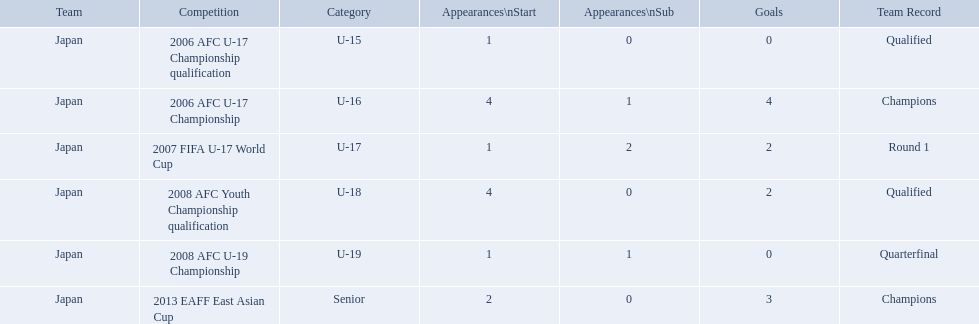Which competitions had champions team records? 2006 AFC U-17 Championship, 2013 EAFF East Asian Cup. Of these competitions, which one was in the senior category? 2013 EAFF East Asian Cup. Which contests featured champion team performances? 2006 AFC U-17 Championship, 2013 EAFF East Asian Cup. Among these contests, which one belonged to the senior category? 2013 EAFF East Asian Cup. In which events did winning teams set records? 2006 AFC U-17 Championship, 2013 EAFF East Asian Cup. Out of these events, which one was within the senior division? 2013 EAFF East Asian Cup. Help me parse the entirety of this table. {'header': ['Team', 'Competition', 'Category', 'Appearances\\nStart', 'Appearances\\nSub', 'Goals', 'Team Record'], 'rows': [['Japan', '2006 AFC U-17 Championship qualification', 'U-15', '1', '0', '0', 'Qualified'], ['Japan', '2006 AFC U-17 Championship', 'U-16', '4', '1', '4', 'Champions'], ['Japan', '2007 FIFA U-17 World Cup', 'U-17', '1', '2', '2', 'Round 1'], ['Japan', '2008 AFC Youth Championship qualification', 'U-18', '4', '0', '2', 'Qualified'], ['Japan', '2008 AFC U-19 Championship', 'U-19', '1', '1', '0', 'Quarterfinal'], ['Japan', '2013 EAFF East Asian Cup', 'Senior', '2', '0', '3', 'Champions']]} What are all the contests? 2006 AFC U-17 Championship qualification, 2006 AFC U-17 Championship, 2007 FIFA U-17 World Cup, 2008 AFC Youth Championship qualification, 2008 AFC U-19 Championship, 2013 EAFF East Asian Cup. How many initial appearances were there? 1, 4, 1, 4, 1, 2. What about specifically during the 2013 eaff east asian cup and the 2007 fifa u-17 world cup? 1, 2. Which of those had more starting appearances? 2013 EAFF East Asian Cup. What are all the tournaments? 2006 AFC U-17 Championship qualification, 2006 AFC U-17 Championship, 2007 FIFA U-17 World Cup, 2008 AFC Youth Championship qualification, 2008 AFC U-19 Championship, 2013 EAFF East Asian Cup. How many opening appearances were there? 1, 4, 1, 4, 1, 2. What about just during the 2013 eaff east asian cup and the 2007 fifa u-17 world cup? 1, 2. Which of those had more initial appearances? 2013 EAFF East Asian Cup. In which contests did japan participate with yoichiro kakitani? 2006 AFC U-17 Championship qualification, 2006 AFC U-17 Championship, 2007 FIFA U-17 World Cup, 2008 AFC Youth Championship qualification, 2008 AFC U-19 Championship, 2013 EAFF East Asian Cup. Among those contests, which took place in 2007 and 2013? 2007 FIFA U-17 World Cup, 2013 EAFF East Asian Cup. Between the 2007 fifa u-17 world cup and the 2013 eaff east asian cup, in which did japan have the highest number of starting appearances? 2013 EAFF East Asian Cup. How many participations were there for each tournament? 1, 4, 1, 4, 1, 2. How many points were there for each tournament? 0, 4, 2, 2, 0, 3. Which tournament(s) has/have the greatest number of participations? 2006 AFC U-17 Championship, 2008 AFC Youth Championship qualification. Which tournament(s) has/have the greatest number of points? 2006 AFC U-17 Championship. What events did japan join in with yoichiro kakitani? 2006 AFC U-17 Championship qualification, 2006 AFC U-17 Championship, 2007 FIFA U-17 World Cup, 2008 AFC Youth Championship qualification, 2008 AFC U-19 Championship, 2013 EAFF East Asian Cup. Out of those events, which occurred in 2007 and 2013? 2007 FIFA U-17 World Cup, 2013 EAFF East Asian Cup. Of the 2007 fifa u-17 world cup and the 2013 eaff east asian cup, which one saw japan with the most starting appearances? 2013 EAFF East Asian Cup. In which contests did the champion teams achieve records? 2006 AFC U-17 Championship, 2013 EAFF East Asian Cup. Among those contests, which one belonged to the senior category? 2013 EAFF East Asian Cup. What was the team's achievement in 2006? Round 1. In which event did they participate? 2006 AFC U-17 Championship. For each competition, what is the total number of appearances? 1, 4, 1, 4, 1, 2. How many goals have been scored in each competition? 0, 4, 2, 2, 0, 3. Which competition(s) boast the greatest number of appearances? 2006 AFC U-17 Championship, 2008 AFC Youth Championship qualification. Which competition(s) have the largest number of goals? 2006 AFC U-17 Championship. 